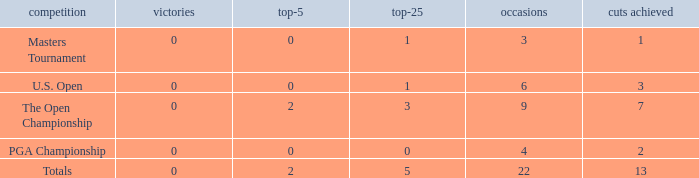What is the fewest wins for Thomas in events he had entered exactly 9 times? 0.0. 